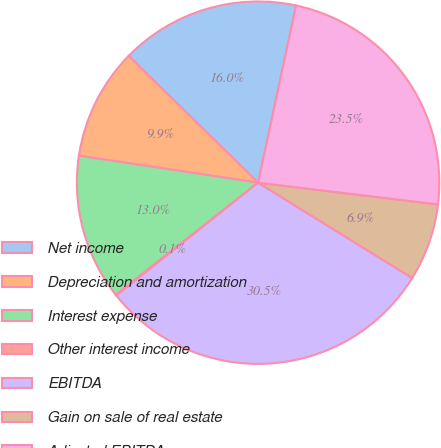Convert chart to OTSL. <chart><loc_0><loc_0><loc_500><loc_500><pie_chart><fcel>Net income<fcel>Depreciation and amortization<fcel>Interest expense<fcel>Other interest income<fcel>EBITDA<fcel>Gain on sale of real estate<fcel>Adjusted EBITDA<nl><fcel>16.03%<fcel>9.95%<fcel>12.99%<fcel>0.1%<fcel>30.47%<fcel>6.91%<fcel>23.55%<nl></chart> 